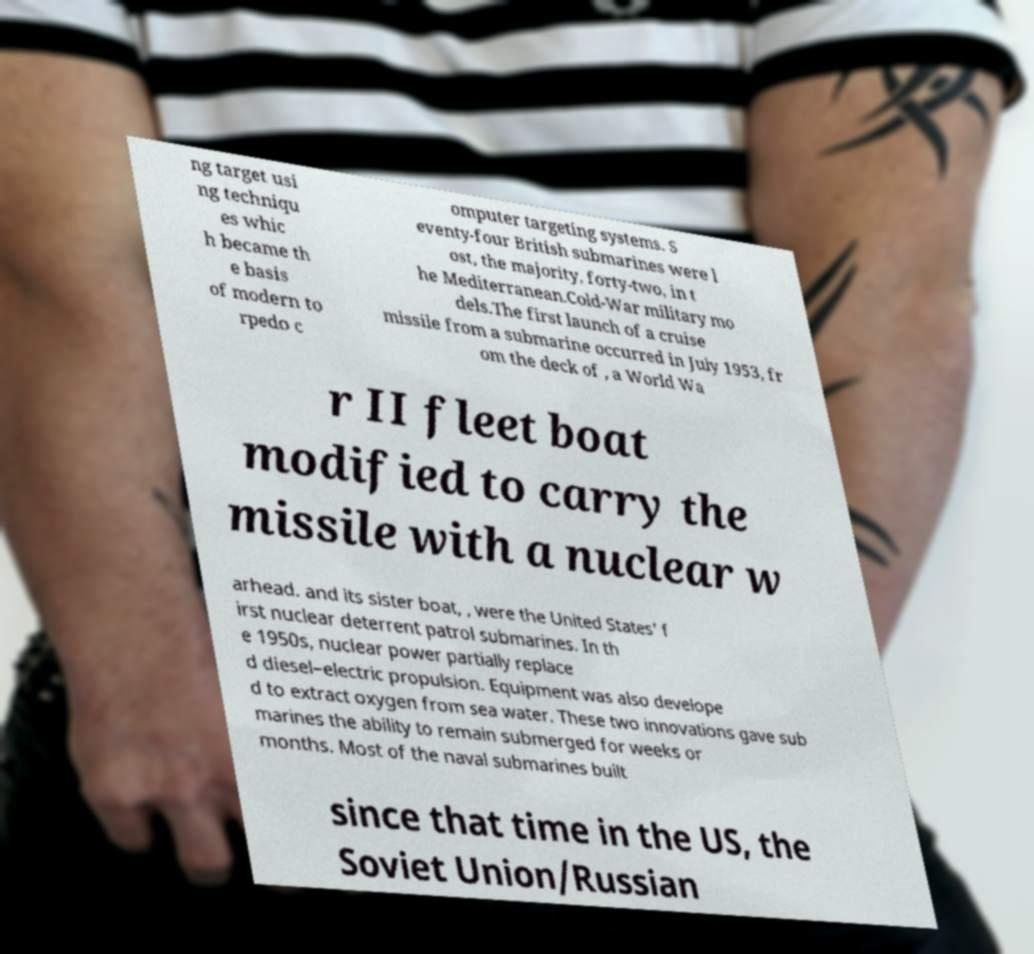For documentation purposes, I need the text within this image transcribed. Could you provide that? ng target usi ng techniqu es whic h became th e basis of modern to rpedo c omputer targeting systems. S eventy-four British submarines were l ost, the majority, forty-two, in t he Mediterranean.Cold-War military mo dels.The first launch of a cruise missile from a submarine occurred in July 1953, fr om the deck of , a World Wa r II fleet boat modified to carry the missile with a nuclear w arhead. and its sister boat, , were the United States' f irst nuclear deterrent patrol submarines. In th e 1950s, nuclear power partially replace d diesel–electric propulsion. Equipment was also develope d to extract oxygen from sea water. These two innovations gave sub marines the ability to remain submerged for weeks or months. Most of the naval submarines built since that time in the US, the Soviet Union/Russian 